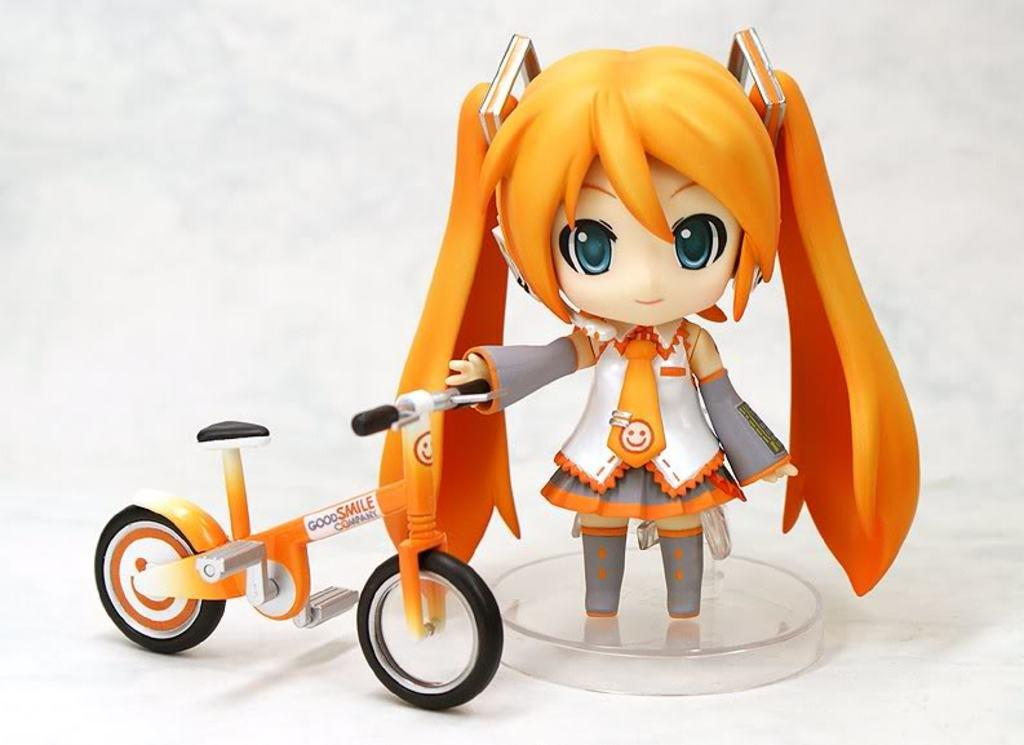What is the main subject of the image? There is a doll in the image. What is the doll holding? The doll is holding a cycle. Is there any text present in the image? Yes, there is text visible in the image. What color is the background of the image? The background of the image is white. How many gloves can be seen in the image? There are no gloves present in the image. What type of channel is depicted in the image? There is no channel depicted in the image. 